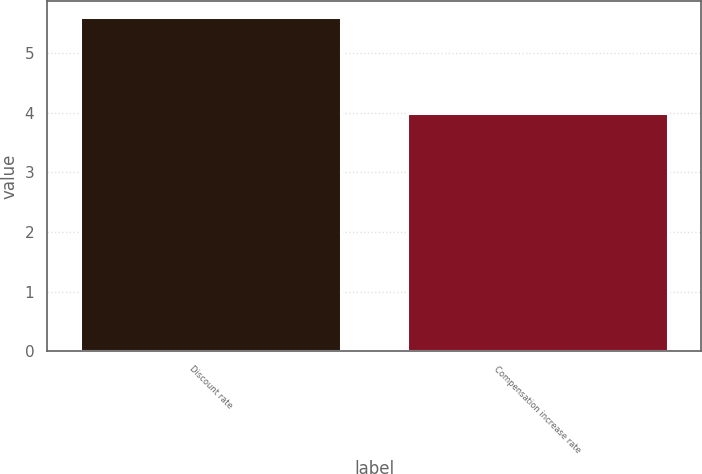Convert chart to OTSL. <chart><loc_0><loc_0><loc_500><loc_500><bar_chart><fcel>Discount rate<fcel>Compensation increase rate<nl><fcel>5.6<fcel>4<nl></chart> 